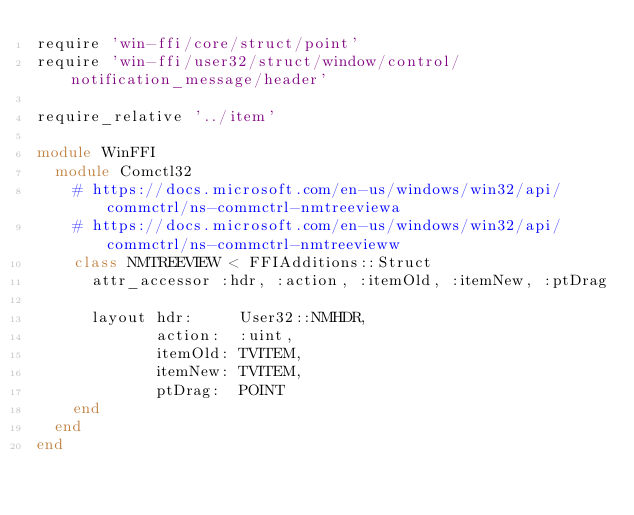Convert code to text. <code><loc_0><loc_0><loc_500><loc_500><_Ruby_>require 'win-ffi/core/struct/point'
require 'win-ffi/user32/struct/window/control/notification_message/header'

require_relative '../item'

module WinFFI
  module Comctl32
    # https://docs.microsoft.com/en-us/windows/win32/api/commctrl/ns-commctrl-nmtreeviewa
    # https://docs.microsoft.com/en-us/windows/win32/api/commctrl/ns-commctrl-nmtreevieww
    class NMTREEVIEW < FFIAdditions::Struct
      attr_accessor :hdr, :action, :itemOld, :itemNew, :ptDrag

      layout hdr:     User32::NMHDR,
             action:  :uint,
             itemOld: TVITEM,
             itemNew: TVITEM,
             ptDrag:  POINT
    end
  end
end</code> 